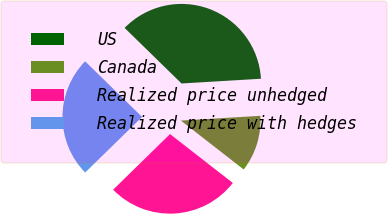<chart> <loc_0><loc_0><loc_500><loc_500><pie_chart><fcel>US<fcel>Canada<fcel>Realized price unhedged<fcel>Realized price with hedges<nl><fcel>36.73%<fcel>11.48%<fcel>27.15%<fcel>24.63%<nl></chart> 